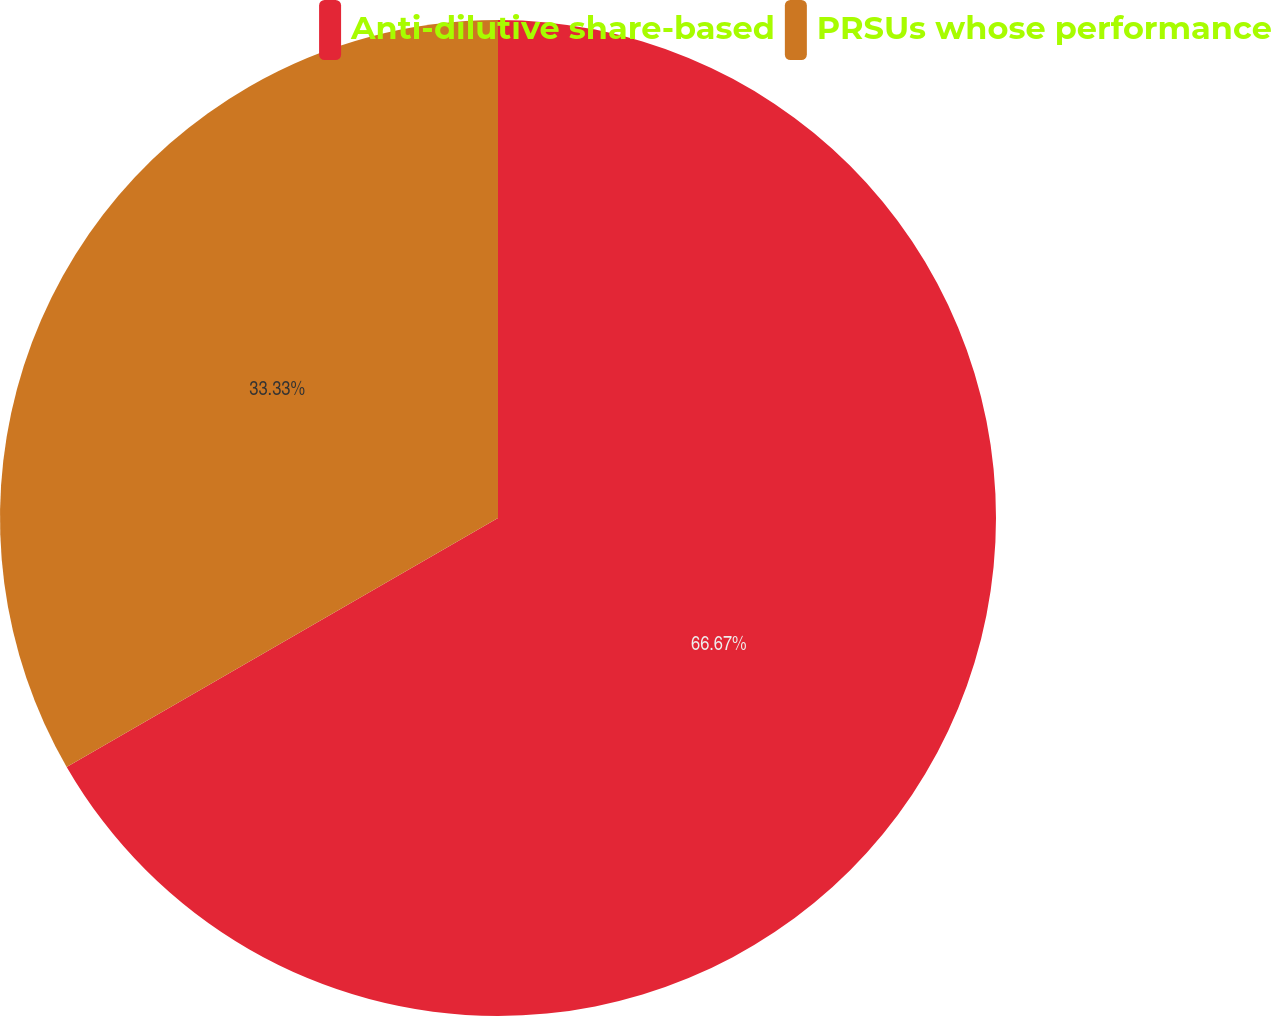Convert chart to OTSL. <chart><loc_0><loc_0><loc_500><loc_500><pie_chart><fcel>Anti-dilutive share-based<fcel>PRSUs whose performance<nl><fcel>66.67%<fcel>33.33%<nl></chart> 